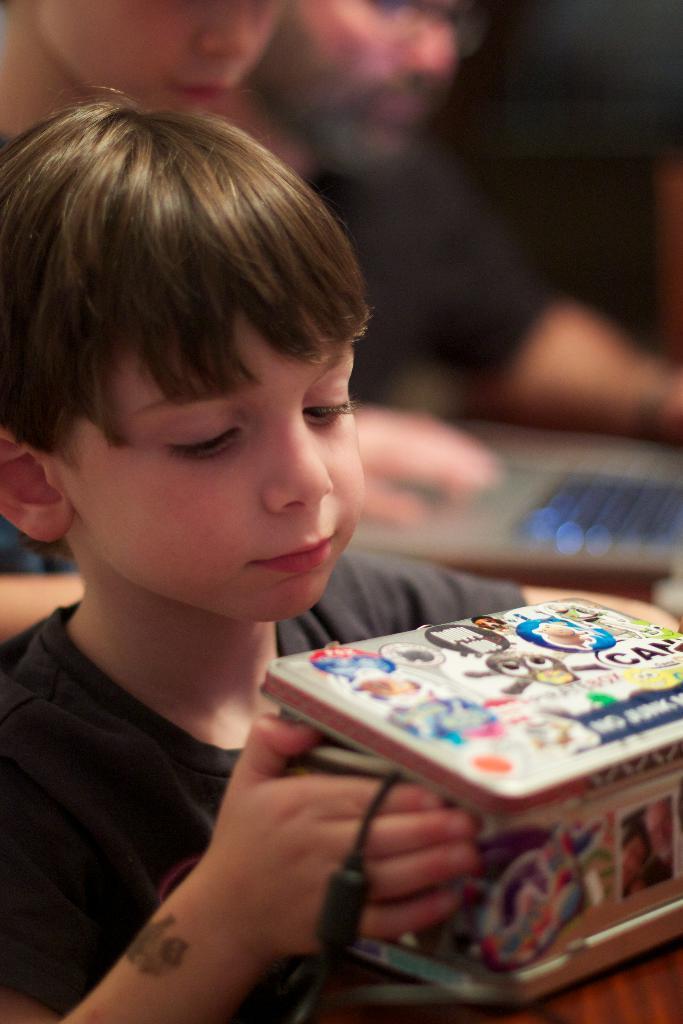Describe this image in one or two sentences. In this image I can see a boy in the front and I can see he is holding a box. I can also see he is wearing grey colour t shirt and on the box I can see number of stickers. In the background I can see two persons, a laptop and I can see this image is little bit blurry in the background. 